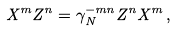Convert formula to latex. <formula><loc_0><loc_0><loc_500><loc_500>X ^ { m } Z ^ { n } = \gamma _ { N } ^ { - m n } Z ^ { n } X ^ { m } \, ,</formula> 